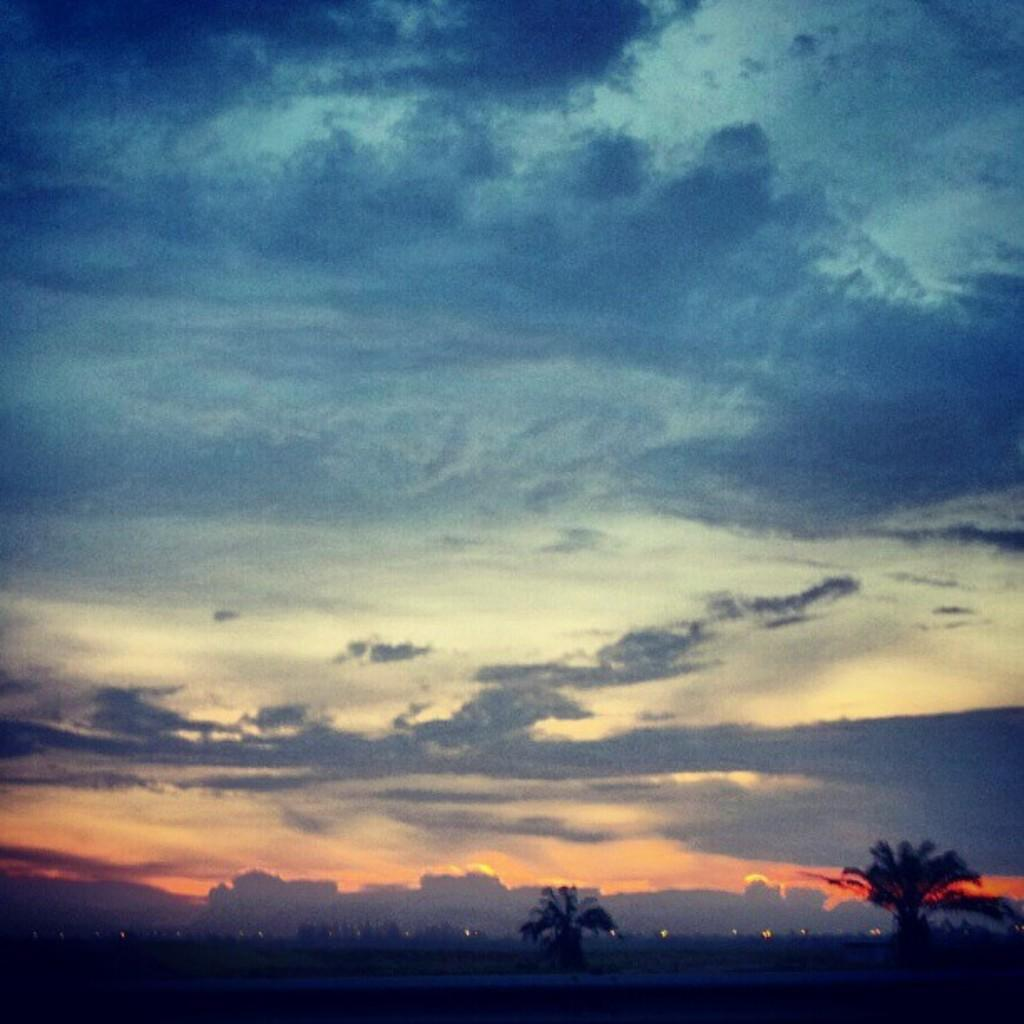What type of natural elements can be seen in the image? There are trees in the image. What type of man-made structures are present in the image? There are buildings in the image. How would you describe the sky in the image? The sky is blue and cloudy in the image. Can you tell me what books are being offered in the library in the image? There is no library present in the image, so it is not possible to determine what books might be offered. 